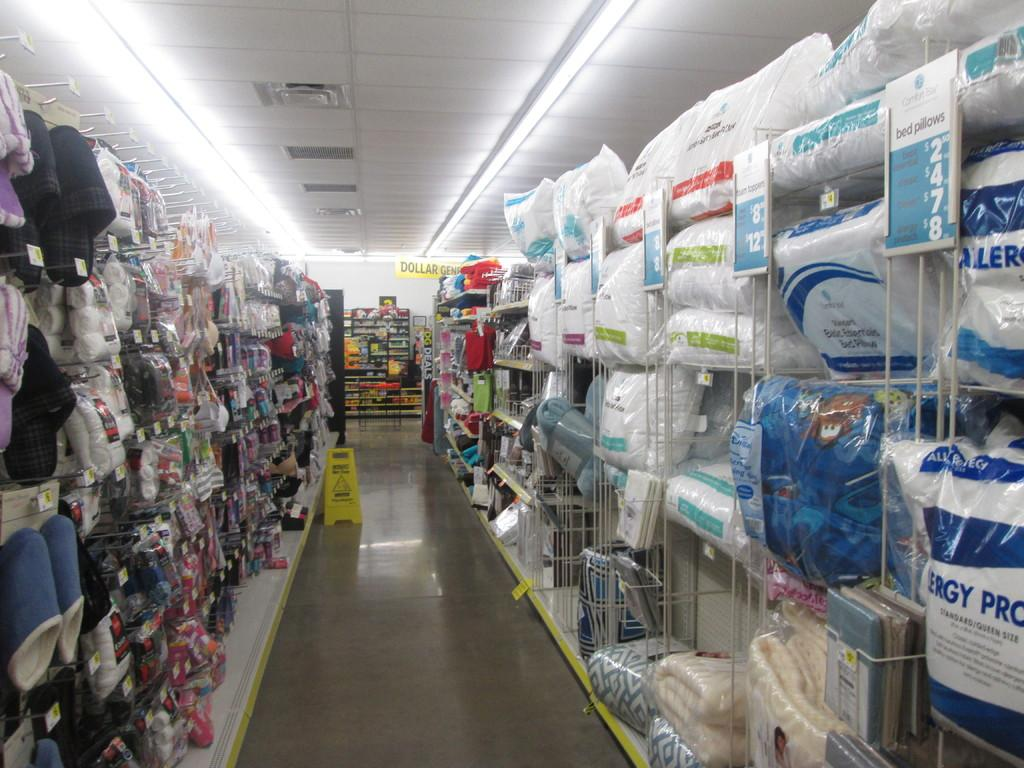<image>
Describe the image concisely. A wet floor sign in an isle displaying things like slippers 